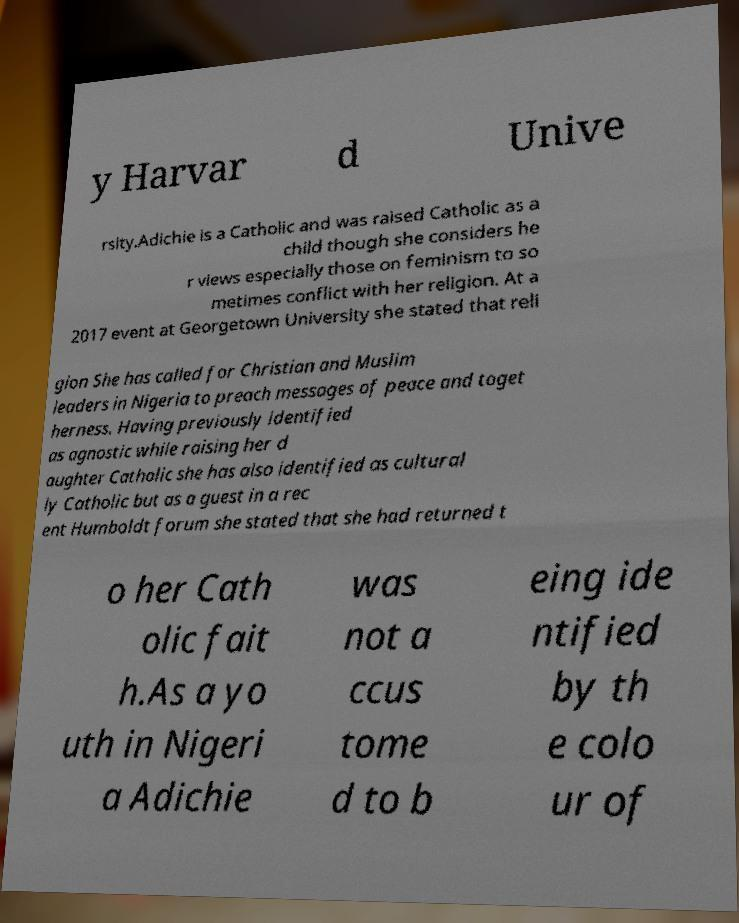There's text embedded in this image that I need extracted. Can you transcribe it verbatim? y Harvar d Unive rsity.Adichie is a Catholic and was raised Catholic as a child though she considers he r views especially those on feminism to so metimes conflict with her religion. At a 2017 event at Georgetown University she stated that reli gion She has called for Christian and Muslim leaders in Nigeria to preach messages of peace and toget herness. Having previously identified as agnostic while raising her d aughter Catholic she has also identified as cultural ly Catholic but as a guest in a rec ent Humboldt forum she stated that she had returned t o her Cath olic fait h.As a yo uth in Nigeri a Adichie was not a ccus tome d to b eing ide ntified by th e colo ur of 